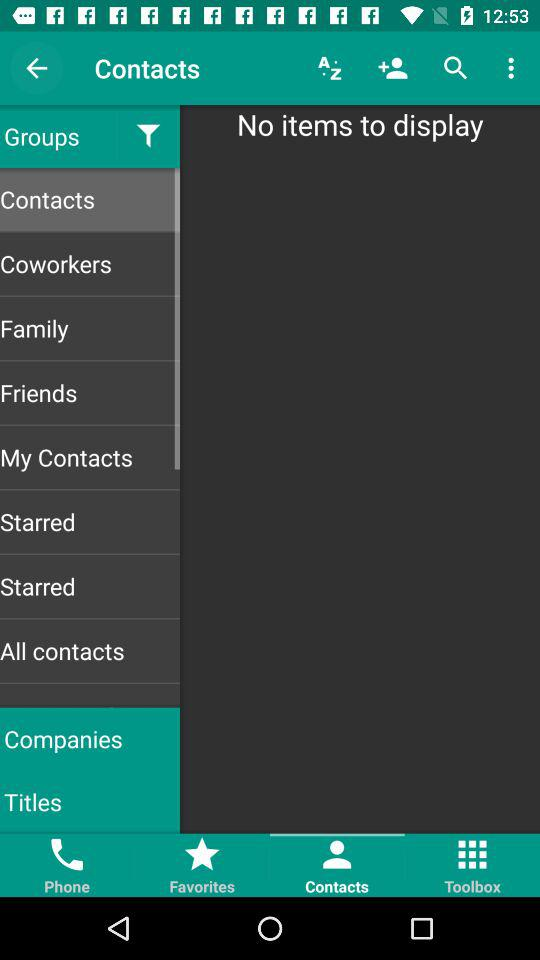Is there any item to display? There are no items to display. 